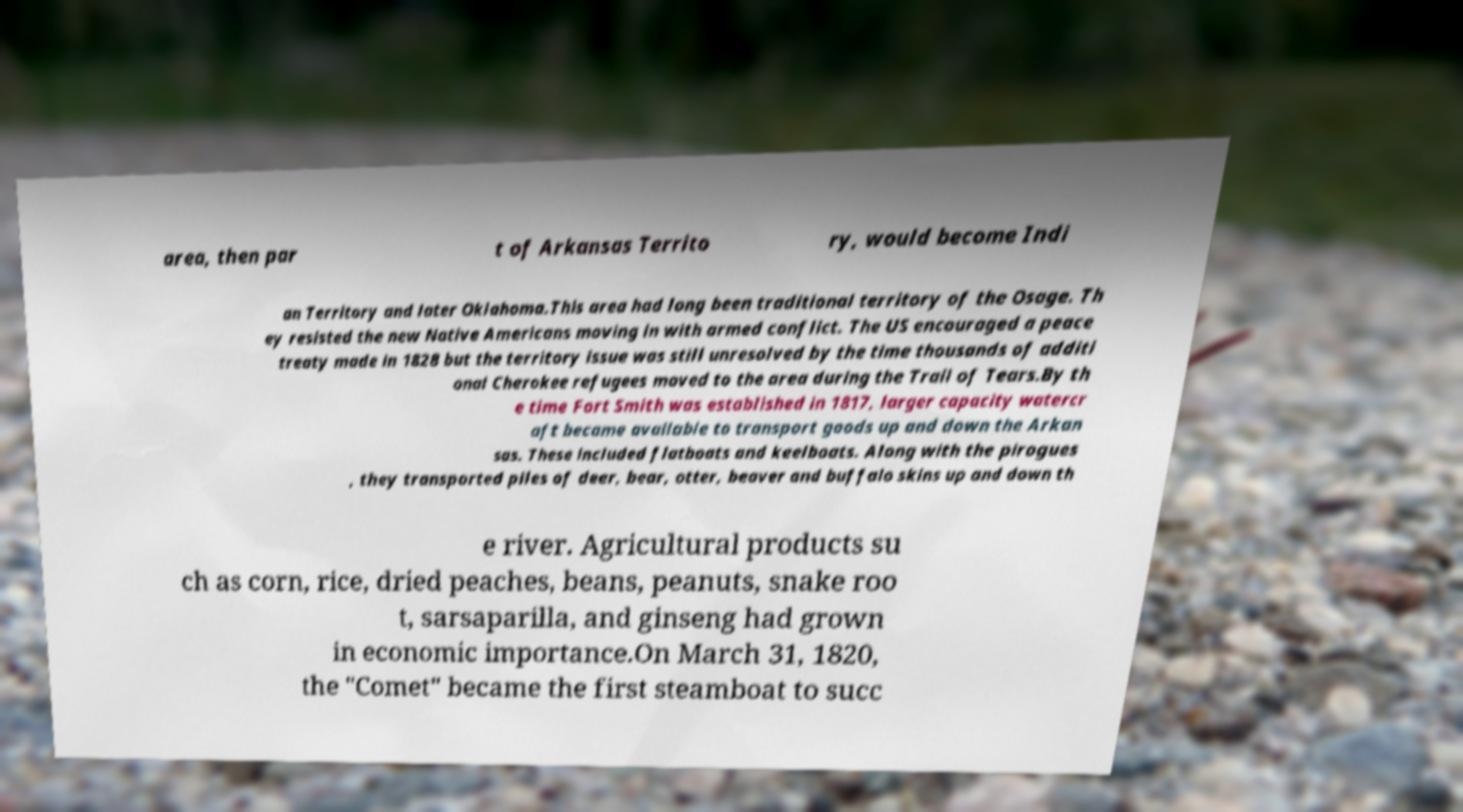Please identify and transcribe the text found in this image. area, then par t of Arkansas Territo ry, would become Indi an Territory and later Oklahoma.This area had long been traditional territory of the Osage. Th ey resisted the new Native Americans moving in with armed conflict. The US encouraged a peace treaty made in 1828 but the territory issue was still unresolved by the time thousands of additi onal Cherokee refugees moved to the area during the Trail of Tears.By th e time Fort Smith was established in 1817, larger capacity watercr aft became available to transport goods up and down the Arkan sas. These included flatboats and keelboats. Along with the pirogues , they transported piles of deer, bear, otter, beaver and buffalo skins up and down th e river. Agricultural products su ch as corn, rice, dried peaches, beans, peanuts, snake roo t, sarsaparilla, and ginseng had grown in economic importance.On March 31, 1820, the "Comet" became the first steamboat to succ 